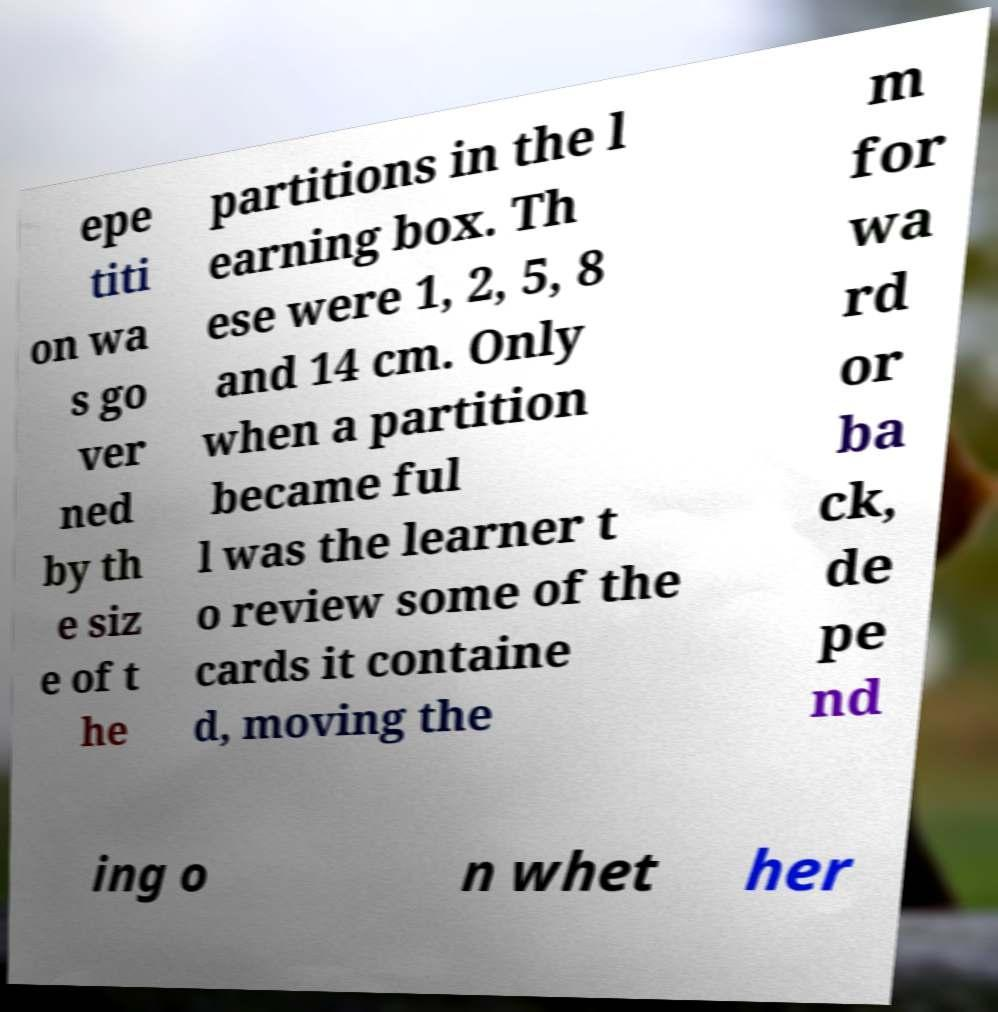Could you extract and type out the text from this image? epe titi on wa s go ver ned by th e siz e of t he partitions in the l earning box. Th ese were 1, 2, 5, 8 and 14 cm. Only when a partition became ful l was the learner t o review some of the cards it containe d, moving the m for wa rd or ba ck, de pe nd ing o n whet her 